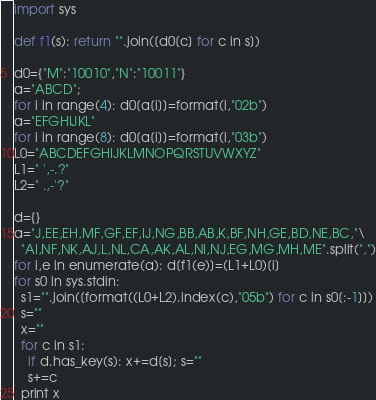<code> <loc_0><loc_0><loc_500><loc_500><_Python_>import sys

def f1(s): return "".join([d0[c] for c in s])

d0={"M":"10010","N":"10011"}
a="ABCD";
for i in range(4): d0[a[i]]=format(i,"02b")
a="EFGHIJKL"
for i in range(8): d0[a[i]]=format(i,"03b")
L0="ABCDEFGHIJKLMNOPQRSTUVWXYZ"
L1=" ',-.?"
L2=" .,-'?"

d={}
a="J,EE,EH,MF,GF,EF,IJ,NG,BB,AB,K,BF,NH,GE,BD,NE,BC,"\
  "AI,NF,NK,AJ,L,NL,CA,AK,AL,NI,NJ,EG,MG,MH,ME".split(",")
for i,e in enumerate(a): d[f1(e)]=(L1+L0)[i]
for s0 in sys.stdin:
  s1="".join([format((L0+L2).index(c),"05b") for c in s0[:-1]])
  s=""
  x=""
  for c in s1:
    if d.has_key(s): x+=d[s]; s=""
    s+=c
  print x</code> 